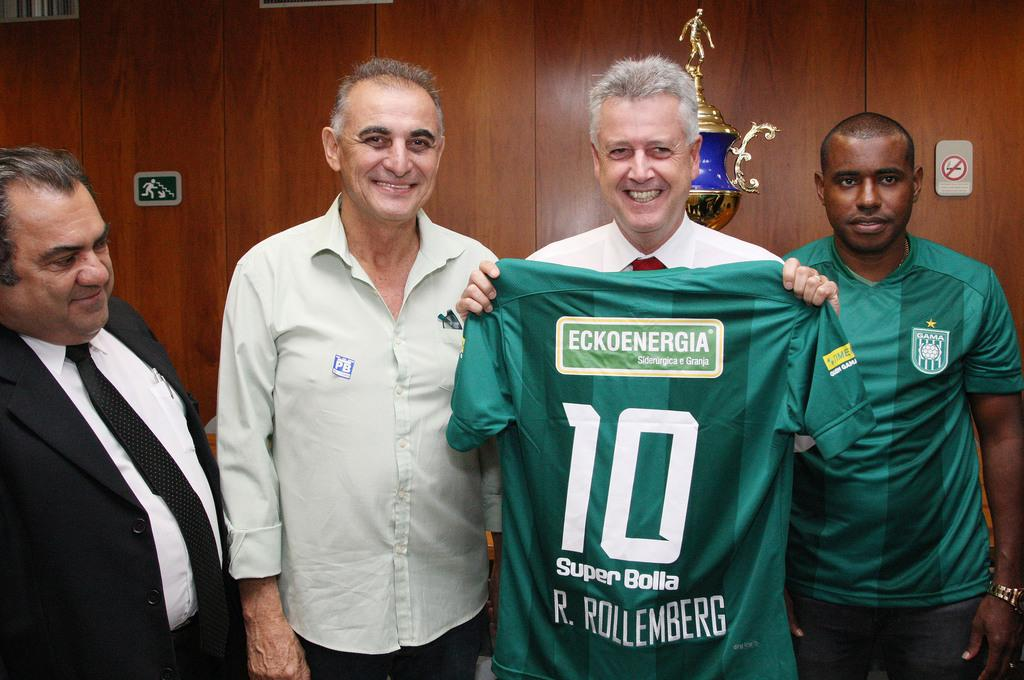<image>
Create a compact narrative representing the image presented. A Green soccer shirt with the number 10 on it being held by a man. 